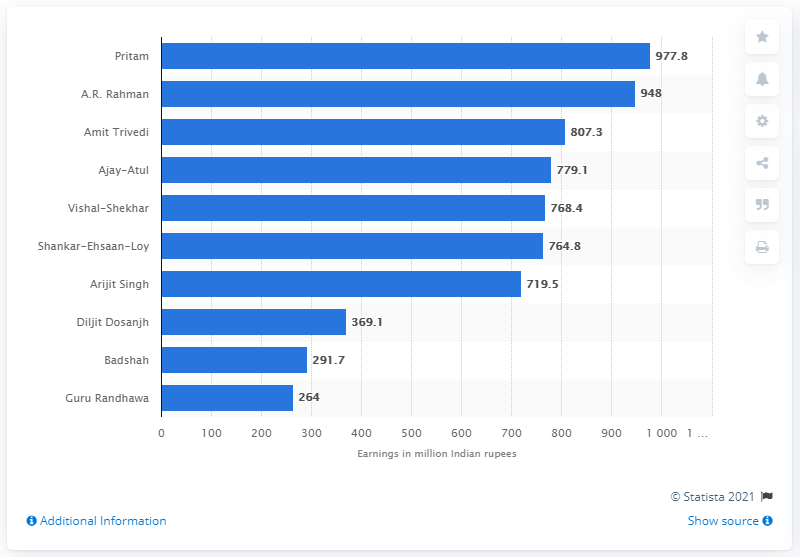Draw attention to some important aspects in this diagram. In 2019, Pritam earned 948 Indian rupees. 